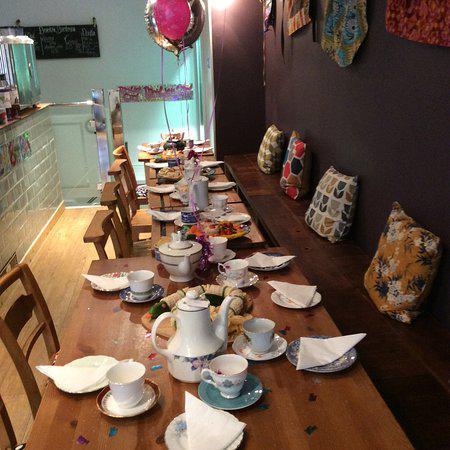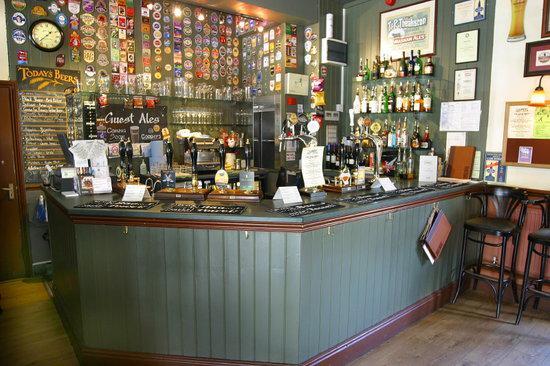The first image is the image on the left, the second image is the image on the right. Assess this claim about the two images: "Each image features baked treats displayed on tiered plates, and porcelain teapots are in the background of at least one image.". Correct or not? Answer yes or no. No. 